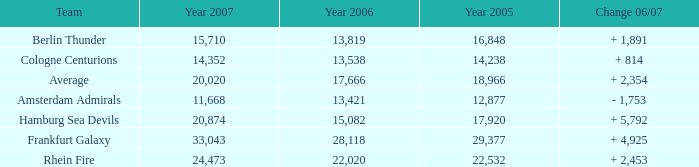What is the Team, when the Year 2007 is greater than 15,710, when the Year 2006 is greater than 17,666, and when the Year 2005 is greater than 22,532? Frankfurt Galaxy. I'm looking to parse the entire table for insights. Could you assist me with that? {'header': ['Team', 'Year 2007', 'Year 2006', 'Year 2005', 'Change 06/07'], 'rows': [['Berlin Thunder', '15,710', '13,819', '16,848', '+ 1,891'], ['Cologne Centurions', '14,352', '13,538', '14,238', '+ 814'], ['Average', '20,020', '17,666', '18,966', '+ 2,354'], ['Amsterdam Admirals', '11,668', '13,421', '12,877', '- 1,753'], ['Hamburg Sea Devils', '20,874', '15,082', '17,920', '+ 5,792'], ['Frankfurt Galaxy', '33,043', '28,118', '29,377', '+ 4,925'], ['Rhein Fire', '24,473', '22,020', '22,532', '+ 2,453']]} 